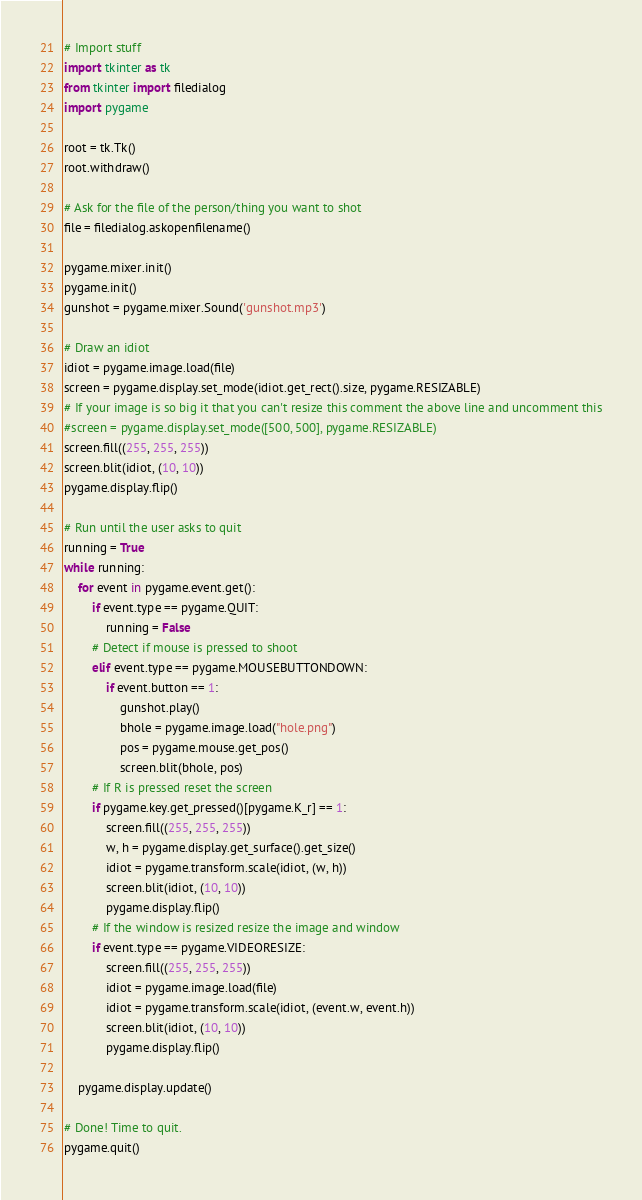<code> <loc_0><loc_0><loc_500><loc_500><_Python_># Import stuff
import tkinter as tk
from tkinter import filedialog
import pygame

root = tk.Tk()
root.withdraw()

# Ask for the file of the person/thing you want to shot
file = filedialog.askopenfilename()

pygame.mixer.init()
pygame.init()
gunshot = pygame.mixer.Sound('gunshot.mp3')

# Draw an idiot
idiot = pygame.image.load(file)
screen = pygame.display.set_mode(idiot.get_rect().size, pygame.RESIZABLE)
# If your image is so big it that you can't resize this comment the above line and uncomment this
#screen = pygame.display.set_mode([500, 500], pygame.RESIZABLE)
screen.fill((255, 255, 255))
screen.blit(idiot, (10, 10))
pygame.display.flip()

# Run until the user asks to quit
running = True
while running:
    for event in pygame.event.get():
        if event.type == pygame.QUIT:
            running = False
        # Detect if mouse is pressed to shoot
        elif event.type == pygame.MOUSEBUTTONDOWN:
            if event.button == 1:
                gunshot.play()
                bhole = pygame.image.load("hole.png")
                pos = pygame.mouse.get_pos()
                screen.blit(bhole, pos)
        # If R is pressed reset the screen
        if pygame.key.get_pressed()[pygame.K_r] == 1:
            screen.fill((255, 255, 255))
            w, h = pygame.display.get_surface().get_size()
            idiot = pygame.transform.scale(idiot, (w, h))
            screen.blit(idiot, (10, 10))
            pygame.display.flip()
        # If the window is resized resize the image and window
        if event.type == pygame.VIDEORESIZE:
            screen.fill((255, 255, 255))
            idiot = pygame.image.load(file)
            idiot = pygame.transform.scale(idiot, (event.w, event.h))
            screen.blit(idiot, (10, 10))
            pygame.display.flip()

    pygame.display.update()

# Done! Time to quit.
pygame.quit()
</code> 